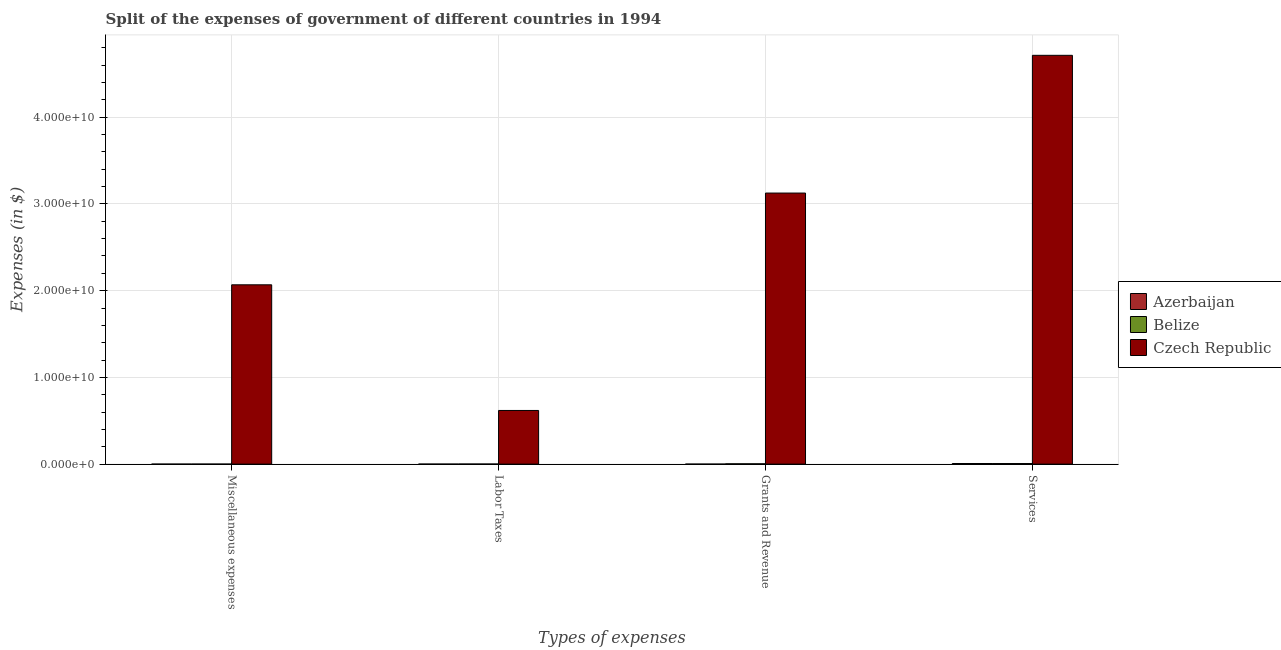How many groups of bars are there?
Keep it short and to the point. 4. Are the number of bars per tick equal to the number of legend labels?
Offer a very short reply. Yes. How many bars are there on the 3rd tick from the left?
Offer a very short reply. 3. What is the label of the 1st group of bars from the left?
Your answer should be very brief. Miscellaneous expenses. What is the amount spent on labor taxes in Czech Republic?
Provide a succinct answer. 6.19e+09. Across all countries, what is the maximum amount spent on grants and revenue?
Your answer should be very brief. 3.13e+1. Across all countries, what is the minimum amount spent on miscellaneous expenses?
Provide a short and direct response. 9.56e+04. In which country was the amount spent on grants and revenue maximum?
Ensure brevity in your answer.  Czech Republic. In which country was the amount spent on services minimum?
Provide a succinct answer. Belize. What is the total amount spent on miscellaneous expenses in the graph?
Make the answer very short. 2.07e+1. What is the difference between the amount spent on miscellaneous expenses in Czech Republic and that in Azerbaijan?
Keep it short and to the point. 2.07e+1. What is the difference between the amount spent on services in Czech Republic and the amount spent on grants and revenue in Azerbaijan?
Provide a succinct answer. 4.71e+1. What is the average amount spent on grants and revenue per country?
Your answer should be compact. 1.04e+1. What is the difference between the amount spent on miscellaneous expenses and amount spent on labor taxes in Azerbaijan?
Your answer should be very brief. -8.84e+05. In how many countries, is the amount spent on services greater than 12000000000 $?
Your response must be concise. 1. What is the ratio of the amount spent on miscellaneous expenses in Czech Republic to that in Azerbaijan?
Your response must be concise. 2.16e+05. Is the difference between the amount spent on services in Czech Republic and Azerbaijan greater than the difference between the amount spent on miscellaneous expenses in Czech Republic and Azerbaijan?
Give a very brief answer. Yes. What is the difference between the highest and the second highest amount spent on labor taxes?
Ensure brevity in your answer.  6.18e+09. What is the difference between the highest and the lowest amount spent on labor taxes?
Your answer should be compact. 6.19e+09. Is it the case that in every country, the sum of the amount spent on labor taxes and amount spent on grants and revenue is greater than the sum of amount spent on services and amount spent on miscellaneous expenses?
Your response must be concise. No. What does the 1st bar from the left in Labor Taxes represents?
Provide a succinct answer. Azerbaijan. What does the 1st bar from the right in Labor Taxes represents?
Your answer should be compact. Czech Republic. Is it the case that in every country, the sum of the amount spent on miscellaneous expenses and amount spent on labor taxes is greater than the amount spent on grants and revenue?
Make the answer very short. No. How many bars are there?
Provide a short and direct response. 12. Are all the bars in the graph horizontal?
Your answer should be compact. No. What is the difference between two consecutive major ticks on the Y-axis?
Your answer should be compact. 1.00e+1. How many legend labels are there?
Your answer should be very brief. 3. How are the legend labels stacked?
Make the answer very short. Vertical. What is the title of the graph?
Offer a terse response. Split of the expenses of government of different countries in 1994. What is the label or title of the X-axis?
Make the answer very short. Types of expenses. What is the label or title of the Y-axis?
Provide a short and direct response. Expenses (in $). What is the Expenses (in $) in Azerbaijan in Miscellaneous expenses?
Offer a terse response. 9.56e+04. What is the Expenses (in $) of Belize in Miscellaneous expenses?
Your answer should be compact. 1.43e+06. What is the Expenses (in $) in Czech Republic in Miscellaneous expenses?
Offer a very short reply. 2.07e+1. What is the Expenses (in $) in Azerbaijan in Labor Taxes?
Give a very brief answer. 9.80e+05. What is the Expenses (in $) in Belize in Labor Taxes?
Your answer should be compact. 8.32e+06. What is the Expenses (in $) of Czech Republic in Labor Taxes?
Your answer should be very brief. 6.19e+09. What is the Expenses (in $) of Azerbaijan in Grants and Revenue?
Your answer should be very brief. 1.71e+05. What is the Expenses (in $) in Belize in Grants and Revenue?
Provide a succinct answer. 3.62e+07. What is the Expenses (in $) in Czech Republic in Grants and Revenue?
Offer a terse response. 3.13e+1. What is the Expenses (in $) in Azerbaijan in Services?
Keep it short and to the point. 7.04e+07. What is the Expenses (in $) in Belize in Services?
Your response must be concise. 6.72e+07. What is the Expenses (in $) of Czech Republic in Services?
Provide a short and direct response. 4.71e+1. Across all Types of expenses, what is the maximum Expenses (in $) of Azerbaijan?
Ensure brevity in your answer.  7.04e+07. Across all Types of expenses, what is the maximum Expenses (in $) in Belize?
Your answer should be compact. 6.72e+07. Across all Types of expenses, what is the maximum Expenses (in $) of Czech Republic?
Offer a very short reply. 4.71e+1. Across all Types of expenses, what is the minimum Expenses (in $) of Azerbaijan?
Give a very brief answer. 9.56e+04. Across all Types of expenses, what is the minimum Expenses (in $) of Belize?
Provide a succinct answer. 1.43e+06. Across all Types of expenses, what is the minimum Expenses (in $) of Czech Republic?
Keep it short and to the point. 6.19e+09. What is the total Expenses (in $) in Azerbaijan in the graph?
Ensure brevity in your answer.  7.17e+07. What is the total Expenses (in $) of Belize in the graph?
Your response must be concise. 1.13e+08. What is the total Expenses (in $) of Czech Republic in the graph?
Provide a short and direct response. 1.05e+11. What is the difference between the Expenses (in $) of Azerbaijan in Miscellaneous expenses and that in Labor Taxes?
Make the answer very short. -8.84e+05. What is the difference between the Expenses (in $) in Belize in Miscellaneous expenses and that in Labor Taxes?
Make the answer very short. -6.89e+06. What is the difference between the Expenses (in $) of Czech Republic in Miscellaneous expenses and that in Labor Taxes?
Offer a very short reply. 1.45e+1. What is the difference between the Expenses (in $) of Azerbaijan in Miscellaneous expenses and that in Grants and Revenue?
Provide a short and direct response. -7.50e+04. What is the difference between the Expenses (in $) of Belize in Miscellaneous expenses and that in Grants and Revenue?
Ensure brevity in your answer.  -3.48e+07. What is the difference between the Expenses (in $) in Czech Republic in Miscellaneous expenses and that in Grants and Revenue?
Your answer should be compact. -1.06e+1. What is the difference between the Expenses (in $) in Azerbaijan in Miscellaneous expenses and that in Services?
Keep it short and to the point. -7.03e+07. What is the difference between the Expenses (in $) in Belize in Miscellaneous expenses and that in Services?
Your answer should be compact. -6.58e+07. What is the difference between the Expenses (in $) in Czech Republic in Miscellaneous expenses and that in Services?
Your answer should be very brief. -2.65e+1. What is the difference between the Expenses (in $) of Azerbaijan in Labor Taxes and that in Grants and Revenue?
Offer a very short reply. 8.09e+05. What is the difference between the Expenses (in $) of Belize in Labor Taxes and that in Grants and Revenue?
Offer a very short reply. -2.79e+07. What is the difference between the Expenses (in $) of Czech Republic in Labor Taxes and that in Grants and Revenue?
Give a very brief answer. -2.51e+1. What is the difference between the Expenses (in $) in Azerbaijan in Labor Taxes and that in Services?
Provide a short and direct response. -6.94e+07. What is the difference between the Expenses (in $) of Belize in Labor Taxes and that in Services?
Make the answer very short. -5.89e+07. What is the difference between the Expenses (in $) in Czech Republic in Labor Taxes and that in Services?
Give a very brief answer. -4.10e+1. What is the difference between the Expenses (in $) in Azerbaijan in Grants and Revenue and that in Services?
Offer a very short reply. -7.03e+07. What is the difference between the Expenses (in $) of Belize in Grants and Revenue and that in Services?
Provide a short and direct response. -3.10e+07. What is the difference between the Expenses (in $) of Czech Republic in Grants and Revenue and that in Services?
Ensure brevity in your answer.  -1.59e+1. What is the difference between the Expenses (in $) of Azerbaijan in Miscellaneous expenses and the Expenses (in $) of Belize in Labor Taxes?
Provide a short and direct response. -8.22e+06. What is the difference between the Expenses (in $) in Azerbaijan in Miscellaneous expenses and the Expenses (in $) in Czech Republic in Labor Taxes?
Make the answer very short. -6.19e+09. What is the difference between the Expenses (in $) in Belize in Miscellaneous expenses and the Expenses (in $) in Czech Republic in Labor Taxes?
Ensure brevity in your answer.  -6.19e+09. What is the difference between the Expenses (in $) in Azerbaijan in Miscellaneous expenses and the Expenses (in $) in Belize in Grants and Revenue?
Make the answer very short. -3.61e+07. What is the difference between the Expenses (in $) of Azerbaijan in Miscellaneous expenses and the Expenses (in $) of Czech Republic in Grants and Revenue?
Offer a very short reply. -3.13e+1. What is the difference between the Expenses (in $) of Belize in Miscellaneous expenses and the Expenses (in $) of Czech Republic in Grants and Revenue?
Ensure brevity in your answer.  -3.13e+1. What is the difference between the Expenses (in $) in Azerbaijan in Miscellaneous expenses and the Expenses (in $) in Belize in Services?
Offer a very short reply. -6.71e+07. What is the difference between the Expenses (in $) of Azerbaijan in Miscellaneous expenses and the Expenses (in $) of Czech Republic in Services?
Offer a terse response. -4.71e+1. What is the difference between the Expenses (in $) of Belize in Miscellaneous expenses and the Expenses (in $) of Czech Republic in Services?
Offer a very short reply. -4.71e+1. What is the difference between the Expenses (in $) in Azerbaijan in Labor Taxes and the Expenses (in $) in Belize in Grants and Revenue?
Your answer should be compact. -3.52e+07. What is the difference between the Expenses (in $) of Azerbaijan in Labor Taxes and the Expenses (in $) of Czech Republic in Grants and Revenue?
Ensure brevity in your answer.  -3.13e+1. What is the difference between the Expenses (in $) of Belize in Labor Taxes and the Expenses (in $) of Czech Republic in Grants and Revenue?
Your answer should be very brief. -3.13e+1. What is the difference between the Expenses (in $) of Azerbaijan in Labor Taxes and the Expenses (in $) of Belize in Services?
Give a very brief answer. -6.62e+07. What is the difference between the Expenses (in $) of Azerbaijan in Labor Taxes and the Expenses (in $) of Czech Republic in Services?
Keep it short and to the point. -4.71e+1. What is the difference between the Expenses (in $) of Belize in Labor Taxes and the Expenses (in $) of Czech Republic in Services?
Give a very brief answer. -4.71e+1. What is the difference between the Expenses (in $) of Azerbaijan in Grants and Revenue and the Expenses (in $) of Belize in Services?
Keep it short and to the point. -6.70e+07. What is the difference between the Expenses (in $) of Azerbaijan in Grants and Revenue and the Expenses (in $) of Czech Republic in Services?
Offer a terse response. -4.71e+1. What is the difference between the Expenses (in $) in Belize in Grants and Revenue and the Expenses (in $) in Czech Republic in Services?
Your answer should be very brief. -4.71e+1. What is the average Expenses (in $) of Azerbaijan per Types of expenses?
Offer a terse response. 1.79e+07. What is the average Expenses (in $) of Belize per Types of expenses?
Offer a terse response. 2.83e+07. What is the average Expenses (in $) of Czech Republic per Types of expenses?
Ensure brevity in your answer.  2.63e+1. What is the difference between the Expenses (in $) in Azerbaijan and Expenses (in $) in Belize in Miscellaneous expenses?
Keep it short and to the point. -1.33e+06. What is the difference between the Expenses (in $) in Azerbaijan and Expenses (in $) in Czech Republic in Miscellaneous expenses?
Your answer should be compact. -2.07e+1. What is the difference between the Expenses (in $) of Belize and Expenses (in $) of Czech Republic in Miscellaneous expenses?
Ensure brevity in your answer.  -2.07e+1. What is the difference between the Expenses (in $) in Azerbaijan and Expenses (in $) in Belize in Labor Taxes?
Offer a terse response. -7.34e+06. What is the difference between the Expenses (in $) in Azerbaijan and Expenses (in $) in Czech Republic in Labor Taxes?
Keep it short and to the point. -6.19e+09. What is the difference between the Expenses (in $) in Belize and Expenses (in $) in Czech Republic in Labor Taxes?
Provide a succinct answer. -6.18e+09. What is the difference between the Expenses (in $) of Azerbaijan and Expenses (in $) of Belize in Grants and Revenue?
Your answer should be compact. -3.60e+07. What is the difference between the Expenses (in $) of Azerbaijan and Expenses (in $) of Czech Republic in Grants and Revenue?
Keep it short and to the point. -3.13e+1. What is the difference between the Expenses (in $) in Belize and Expenses (in $) in Czech Republic in Grants and Revenue?
Make the answer very short. -3.12e+1. What is the difference between the Expenses (in $) of Azerbaijan and Expenses (in $) of Belize in Services?
Keep it short and to the point. 3.25e+06. What is the difference between the Expenses (in $) of Azerbaijan and Expenses (in $) of Czech Republic in Services?
Provide a short and direct response. -4.71e+1. What is the difference between the Expenses (in $) in Belize and Expenses (in $) in Czech Republic in Services?
Your answer should be compact. -4.71e+1. What is the ratio of the Expenses (in $) in Azerbaijan in Miscellaneous expenses to that in Labor Taxes?
Ensure brevity in your answer.  0.1. What is the ratio of the Expenses (in $) of Belize in Miscellaneous expenses to that in Labor Taxes?
Your response must be concise. 0.17. What is the ratio of the Expenses (in $) of Czech Republic in Miscellaneous expenses to that in Labor Taxes?
Offer a terse response. 3.34. What is the ratio of the Expenses (in $) in Azerbaijan in Miscellaneous expenses to that in Grants and Revenue?
Keep it short and to the point. 0.56. What is the ratio of the Expenses (in $) in Belize in Miscellaneous expenses to that in Grants and Revenue?
Offer a very short reply. 0.04. What is the ratio of the Expenses (in $) in Czech Republic in Miscellaneous expenses to that in Grants and Revenue?
Keep it short and to the point. 0.66. What is the ratio of the Expenses (in $) of Azerbaijan in Miscellaneous expenses to that in Services?
Ensure brevity in your answer.  0. What is the ratio of the Expenses (in $) of Belize in Miscellaneous expenses to that in Services?
Provide a succinct answer. 0.02. What is the ratio of the Expenses (in $) in Czech Republic in Miscellaneous expenses to that in Services?
Offer a terse response. 0.44. What is the ratio of the Expenses (in $) in Azerbaijan in Labor Taxes to that in Grants and Revenue?
Give a very brief answer. 5.74. What is the ratio of the Expenses (in $) in Belize in Labor Taxes to that in Grants and Revenue?
Keep it short and to the point. 0.23. What is the ratio of the Expenses (in $) in Czech Republic in Labor Taxes to that in Grants and Revenue?
Provide a succinct answer. 0.2. What is the ratio of the Expenses (in $) in Azerbaijan in Labor Taxes to that in Services?
Offer a very short reply. 0.01. What is the ratio of the Expenses (in $) of Belize in Labor Taxes to that in Services?
Your answer should be very brief. 0.12. What is the ratio of the Expenses (in $) of Czech Republic in Labor Taxes to that in Services?
Your answer should be compact. 0.13. What is the ratio of the Expenses (in $) of Azerbaijan in Grants and Revenue to that in Services?
Ensure brevity in your answer.  0. What is the ratio of the Expenses (in $) of Belize in Grants and Revenue to that in Services?
Your answer should be very brief. 0.54. What is the ratio of the Expenses (in $) in Czech Republic in Grants and Revenue to that in Services?
Make the answer very short. 0.66. What is the difference between the highest and the second highest Expenses (in $) in Azerbaijan?
Your answer should be compact. 6.94e+07. What is the difference between the highest and the second highest Expenses (in $) of Belize?
Your answer should be compact. 3.10e+07. What is the difference between the highest and the second highest Expenses (in $) in Czech Republic?
Provide a succinct answer. 1.59e+1. What is the difference between the highest and the lowest Expenses (in $) in Azerbaijan?
Give a very brief answer. 7.03e+07. What is the difference between the highest and the lowest Expenses (in $) in Belize?
Your answer should be very brief. 6.58e+07. What is the difference between the highest and the lowest Expenses (in $) in Czech Republic?
Provide a succinct answer. 4.10e+1. 